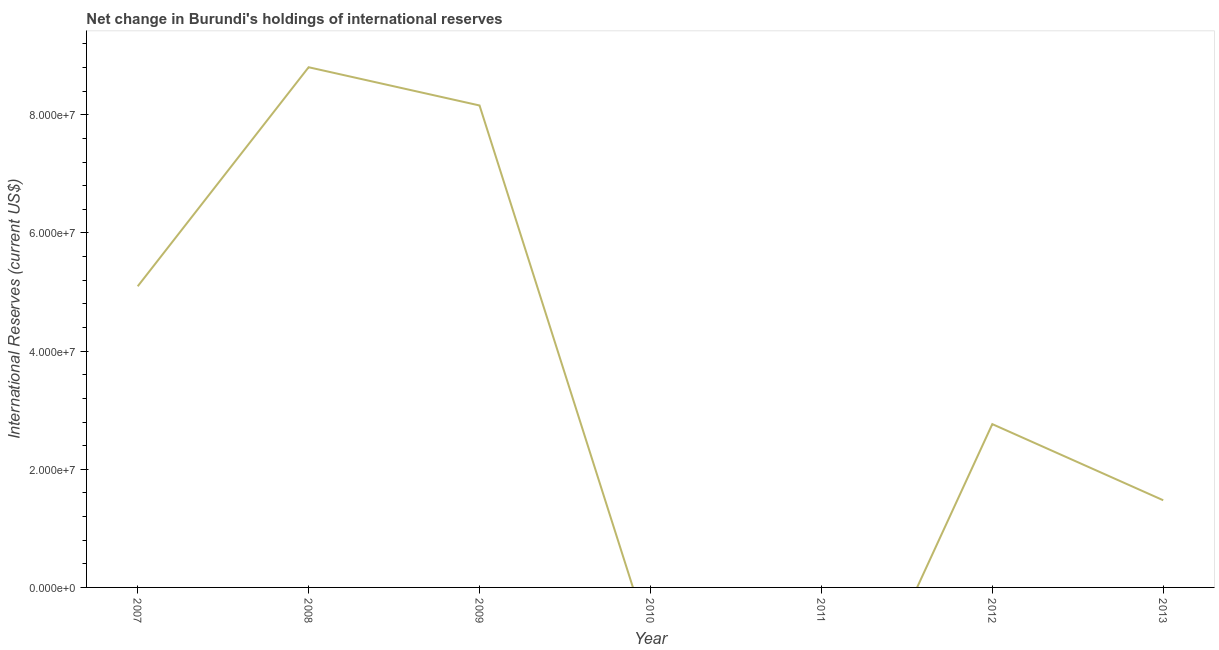What is the reserves and related items in 2013?
Ensure brevity in your answer.  1.48e+07. Across all years, what is the maximum reserves and related items?
Provide a succinct answer. 8.81e+07. What is the sum of the reserves and related items?
Provide a short and direct response. 2.63e+08. What is the difference between the reserves and related items in 2007 and 2009?
Offer a terse response. -3.06e+07. What is the average reserves and related items per year?
Keep it short and to the point. 3.76e+07. What is the median reserves and related items?
Your response must be concise. 2.76e+07. What is the ratio of the reserves and related items in 2008 to that in 2012?
Your response must be concise. 3.19. What is the difference between the highest and the second highest reserves and related items?
Your answer should be compact. 6.47e+06. What is the difference between the highest and the lowest reserves and related items?
Give a very brief answer. 8.81e+07. In how many years, is the reserves and related items greater than the average reserves and related items taken over all years?
Your answer should be very brief. 3. Does the reserves and related items monotonically increase over the years?
Your answer should be very brief. No. How many lines are there?
Provide a short and direct response. 1. What is the difference between two consecutive major ticks on the Y-axis?
Provide a succinct answer. 2.00e+07. Are the values on the major ticks of Y-axis written in scientific E-notation?
Offer a very short reply. Yes. Does the graph contain grids?
Offer a terse response. No. What is the title of the graph?
Your answer should be compact. Net change in Burundi's holdings of international reserves. What is the label or title of the Y-axis?
Ensure brevity in your answer.  International Reserves (current US$). What is the International Reserves (current US$) of 2007?
Offer a terse response. 5.10e+07. What is the International Reserves (current US$) of 2008?
Keep it short and to the point. 8.81e+07. What is the International Reserves (current US$) in 2009?
Offer a terse response. 8.16e+07. What is the International Reserves (current US$) in 2010?
Provide a short and direct response. 0. What is the International Reserves (current US$) of 2012?
Keep it short and to the point. 2.76e+07. What is the International Reserves (current US$) in 2013?
Give a very brief answer. 1.48e+07. What is the difference between the International Reserves (current US$) in 2007 and 2008?
Offer a very short reply. -3.71e+07. What is the difference between the International Reserves (current US$) in 2007 and 2009?
Keep it short and to the point. -3.06e+07. What is the difference between the International Reserves (current US$) in 2007 and 2012?
Make the answer very short. 2.33e+07. What is the difference between the International Reserves (current US$) in 2007 and 2013?
Ensure brevity in your answer.  3.62e+07. What is the difference between the International Reserves (current US$) in 2008 and 2009?
Your answer should be compact. 6.47e+06. What is the difference between the International Reserves (current US$) in 2008 and 2012?
Provide a short and direct response. 6.04e+07. What is the difference between the International Reserves (current US$) in 2008 and 2013?
Offer a very short reply. 7.33e+07. What is the difference between the International Reserves (current US$) in 2009 and 2012?
Your answer should be very brief. 5.39e+07. What is the difference between the International Reserves (current US$) in 2009 and 2013?
Your response must be concise. 6.68e+07. What is the difference between the International Reserves (current US$) in 2012 and 2013?
Your answer should be very brief. 1.29e+07. What is the ratio of the International Reserves (current US$) in 2007 to that in 2008?
Your response must be concise. 0.58. What is the ratio of the International Reserves (current US$) in 2007 to that in 2009?
Keep it short and to the point. 0.62. What is the ratio of the International Reserves (current US$) in 2007 to that in 2012?
Keep it short and to the point. 1.84. What is the ratio of the International Reserves (current US$) in 2007 to that in 2013?
Ensure brevity in your answer.  3.46. What is the ratio of the International Reserves (current US$) in 2008 to that in 2009?
Your answer should be compact. 1.08. What is the ratio of the International Reserves (current US$) in 2008 to that in 2012?
Ensure brevity in your answer.  3.19. What is the ratio of the International Reserves (current US$) in 2008 to that in 2013?
Offer a very short reply. 5.97. What is the ratio of the International Reserves (current US$) in 2009 to that in 2012?
Make the answer very short. 2.95. What is the ratio of the International Reserves (current US$) in 2009 to that in 2013?
Your answer should be compact. 5.53. What is the ratio of the International Reserves (current US$) in 2012 to that in 2013?
Give a very brief answer. 1.87. 